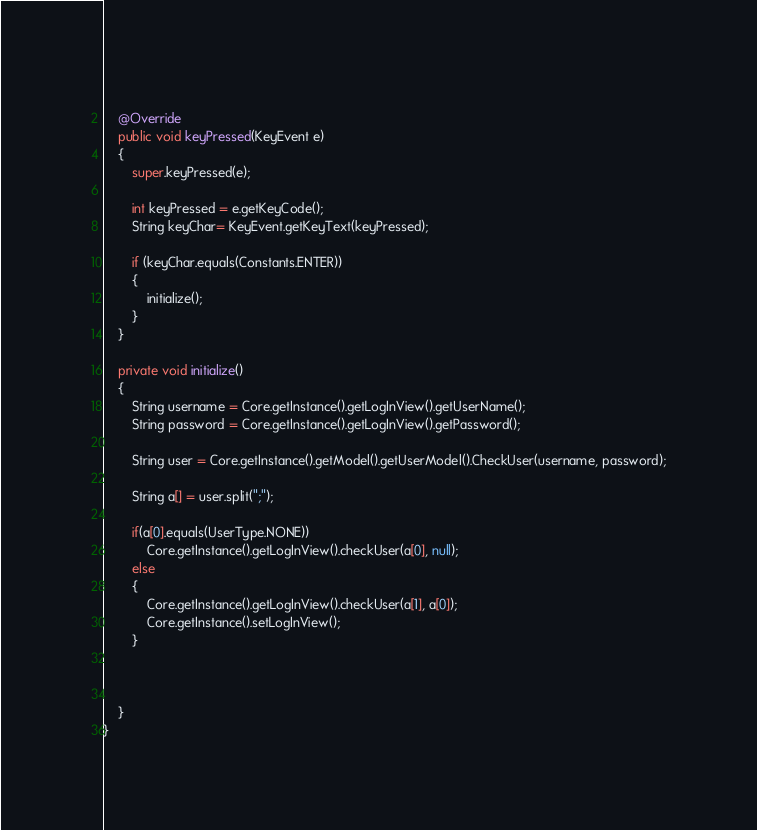Convert code to text. <code><loc_0><loc_0><loc_500><loc_500><_Java_>	
	@Override
	public void keyPressed(KeyEvent e)
	{
		super.keyPressed(e);
		
		int keyPressed = e.getKeyCode();
		String keyChar= KeyEvent.getKeyText(keyPressed);
		
		if (keyChar.equals(Constants.ENTER))
		{
			initialize();
		}
	}
	
	private void initialize()
	{
		String username = Core.getInstance().getLogInView().getUserName();
		String password = Core.getInstance().getLogInView().getPassword();
		
		String user = Core.getInstance().getModel().getUserModel().CheckUser(username, password);
		
		String a[] = user.split(";");
		
		if(a[0].equals(UserType.NONE))
			Core.getInstance().getLogInView().checkUser(a[0], null);
		else
		{
			Core.getInstance().getLogInView().checkUser(a[1], a[0]);
			Core.getInstance().setLogInView();
		}
			
		
		
	}
}
</code> 